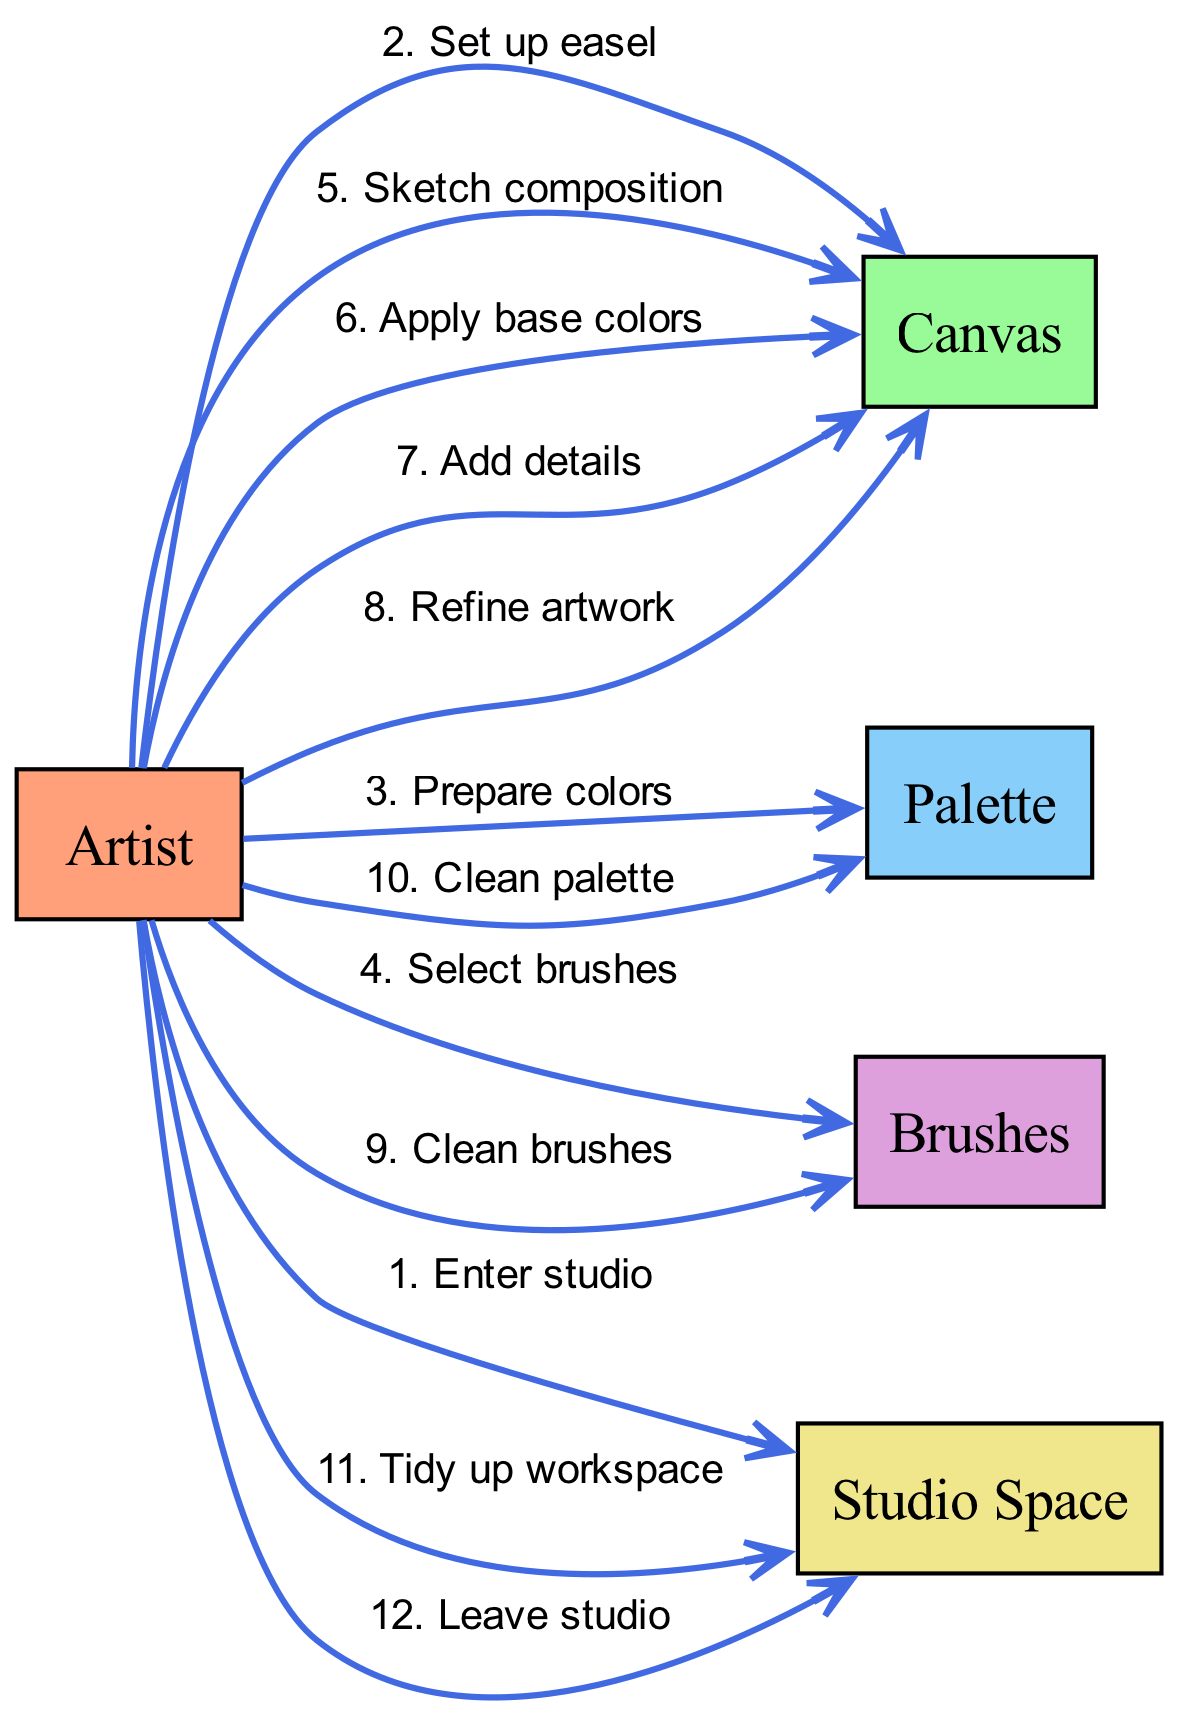What is the first action taken by the Artist? The diagram indicates that the first action taken by the Artist is to "Enter studio," which is the first edge connected to the "Studio Space."
Answer: Enter studio How many actions are taken involving the Canvas? To determine this, we can count the edges originating from the Artist to the Canvas. There are four actions: "Set up easel," "Sketch composition," "Apply base colors," and "Add details," totaling four actions.
Answer: 4 What action follows "Prepare colors"? The action that follows "Prepare colors" in the sequence is "Select brushes," which is the next connected edge after that action.
Answer: Select brushes What is the last action performed by the Artist? The diagram shows that the last action performed by the Artist is "Leave studio," represented as the final edge in the sequence leading to the Studio Space.
Answer: Leave studio How many actors are involved in the diagram? The diagram lists five unique actors: Artist, Canvas, Palette, Brushes, and Studio Space. Therefore, the total number of actors is five.
Answer: 5 Identify a pair of actions that involve cleaning. In the diagram, the actions involving cleaning are "Clean brushes" and "Clean palette." These actions illustrate the cleaning process after finishing the artwork.
Answer: Clean brushes, Clean palette What is the action immediately before "Tidy up workspace"? The action that immediately precedes "Tidy up workspace" is "Clean palette." This sequence indicates the steps taken to ensure everything is cleaned before tidying up the overall workspace.
Answer: Clean palette Which action occurs most frequently in the sequence? The action "Apply base colors" occurs once, but the other actions either precede or follow it, making it relevant. However, "Sketch composition" and "Add details" have been performed singularly as well. Thus, no action repeats multiple times.
Answer: No action repeats What is the total number of edges in the sequence diagram? The sequence contains twelve actions, resulting in twelve edges connecting various actors based on actions taken, highlighting the flow of proceedings in the studio.
Answer: 12 